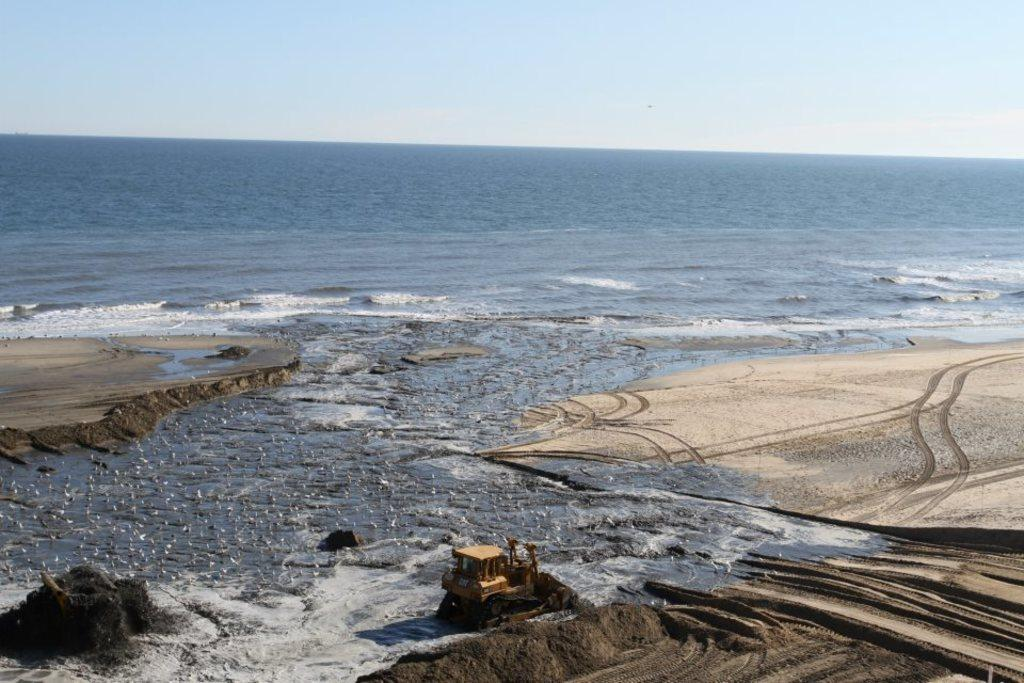What object is on the sand in the image? There is a proclainer on the sand. What type of animals can be seen in the image? Birds are visible in the image. What is the setting of the image? The image appears to be a seashore. What body of water is visible in the image? The sea is visible in the image. What is a characteristic of the sea in the image? There is water in the sea. What type of force is being applied to the spoon in the image? There is no spoon present in the image, so it is not possible to determine if any force is being applied to it. 